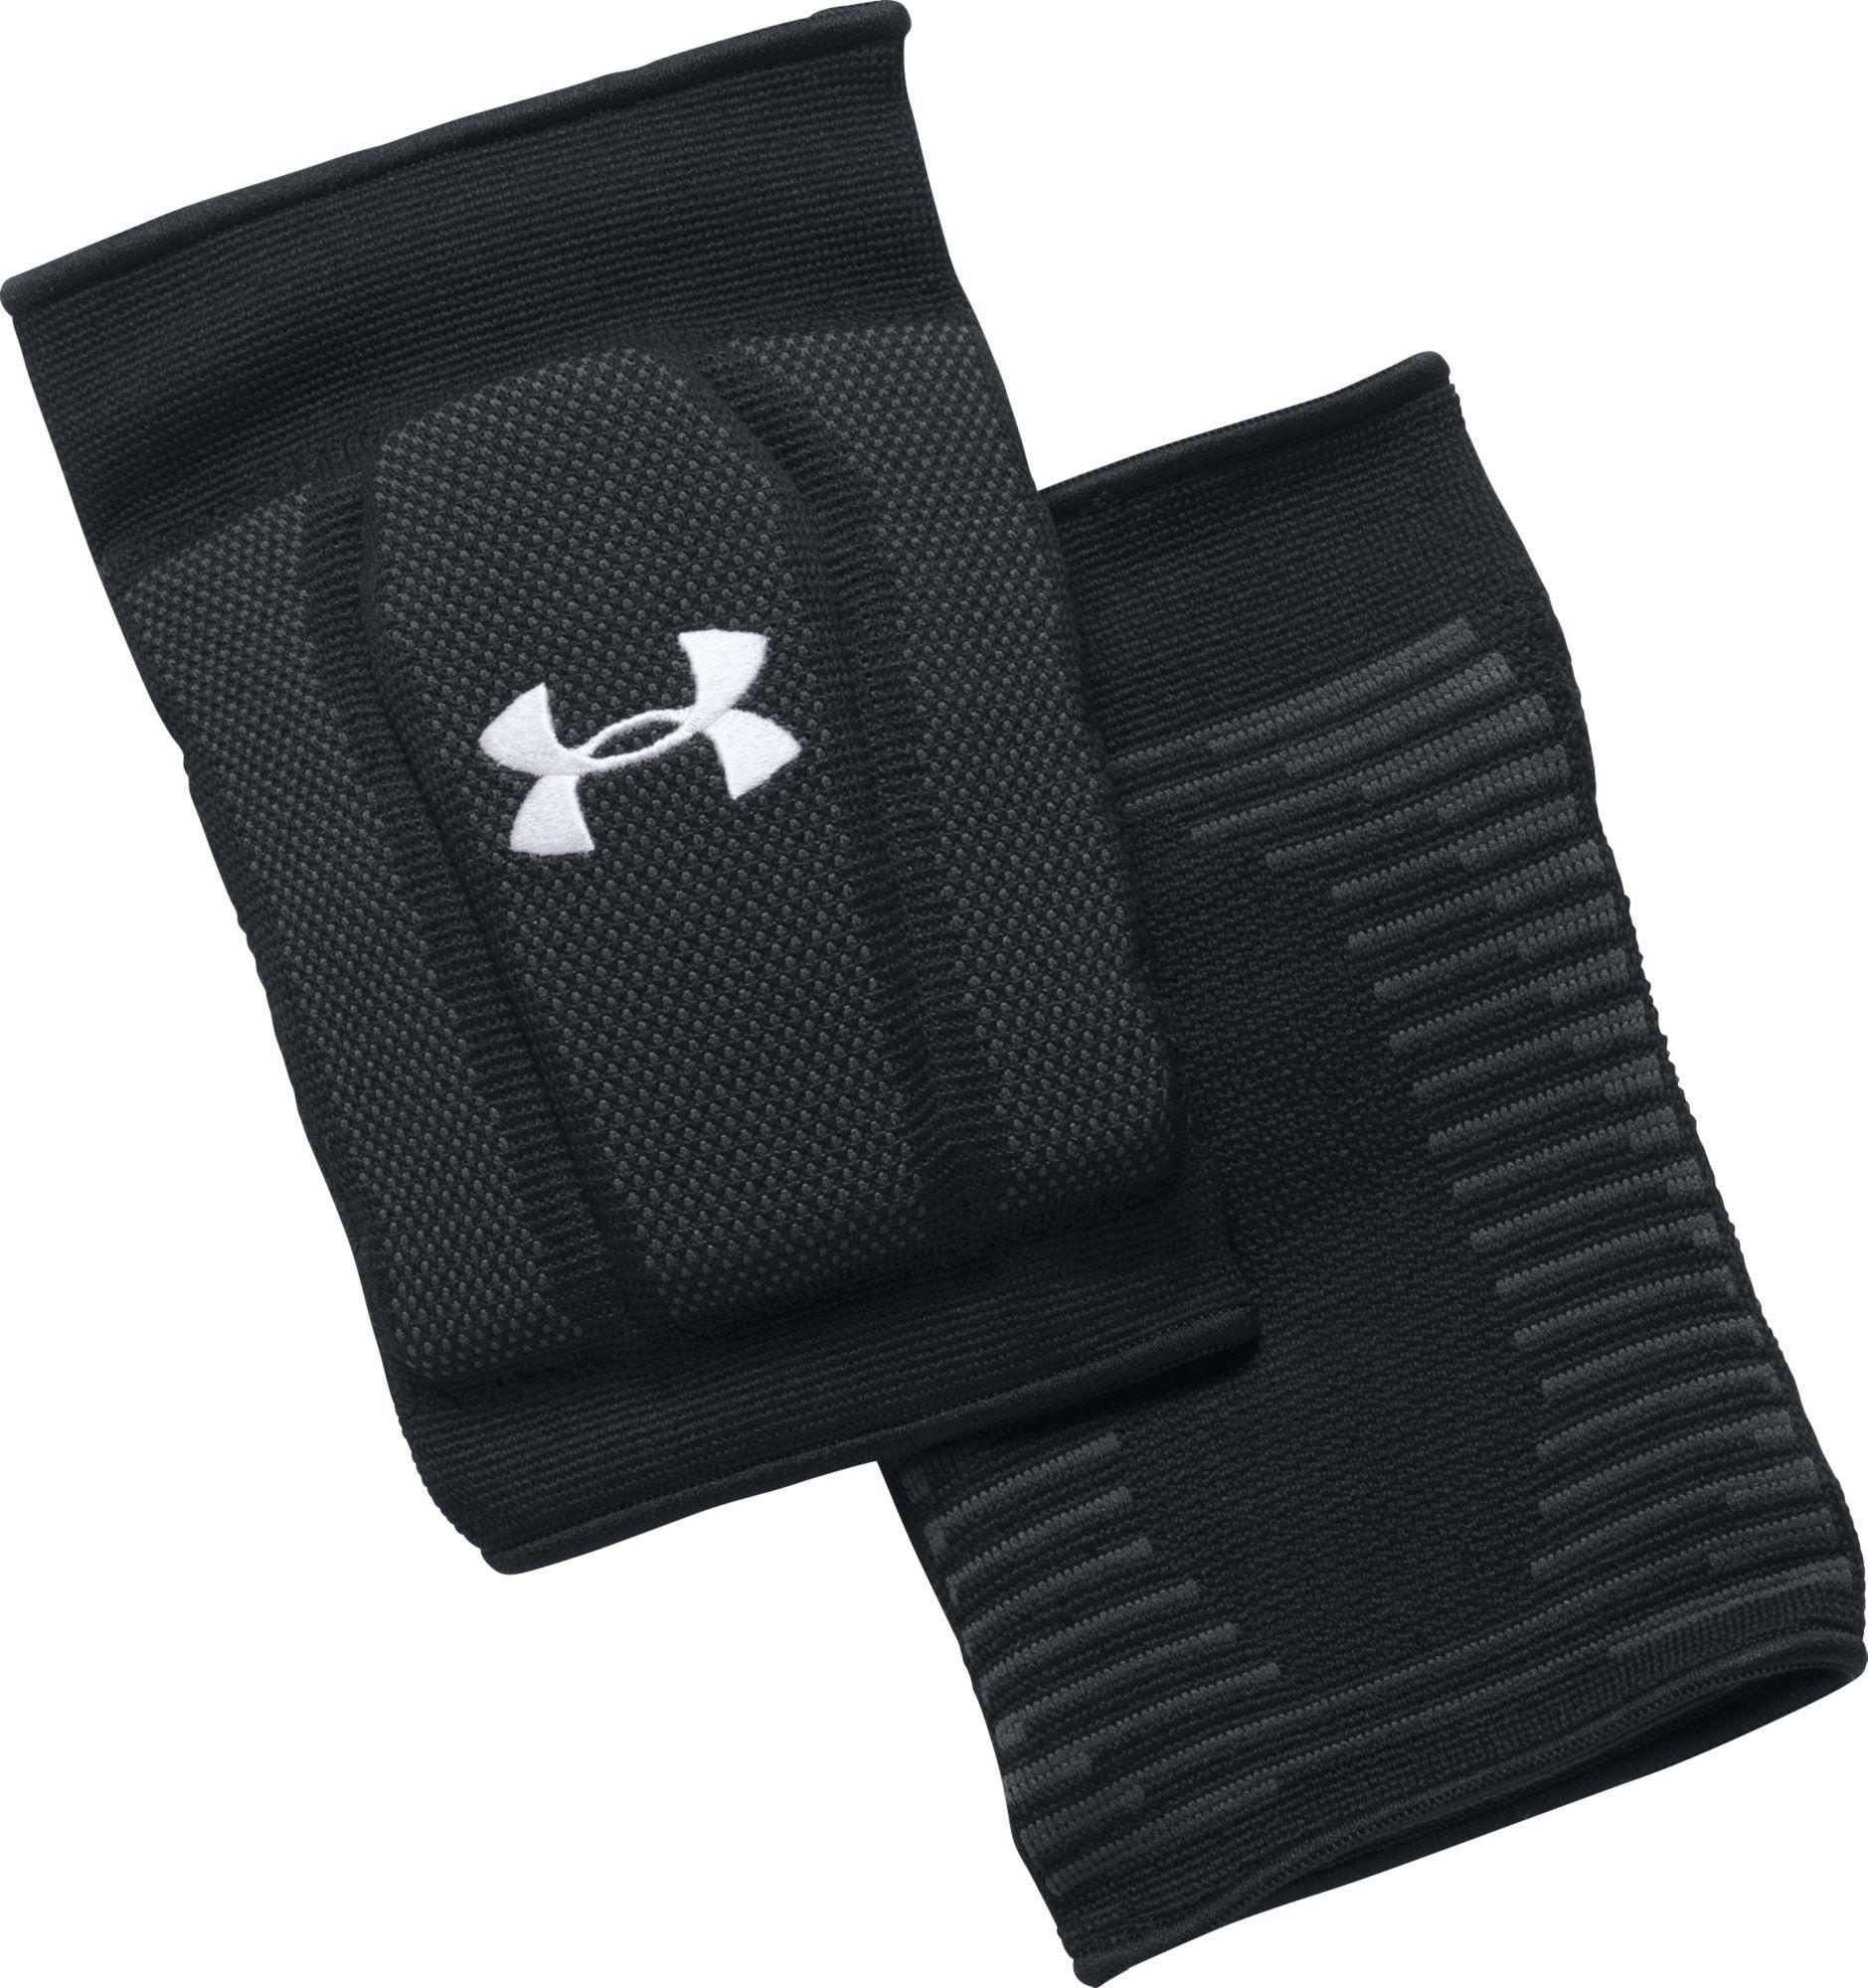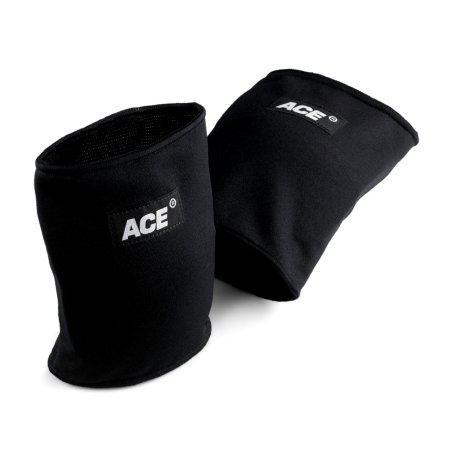The first image is the image on the left, the second image is the image on the right. Analyze the images presented: Is the assertion "There are two pairs of knee pads laying flat." valid? Answer yes or no. No. The first image is the image on the left, the second image is the image on the right. Examine the images to the left and right. Is the description "Each image contains one pair of black knee pads, but only one image features a pair of knee pads with logos visible on each pad." accurate? Answer yes or no. Yes. 